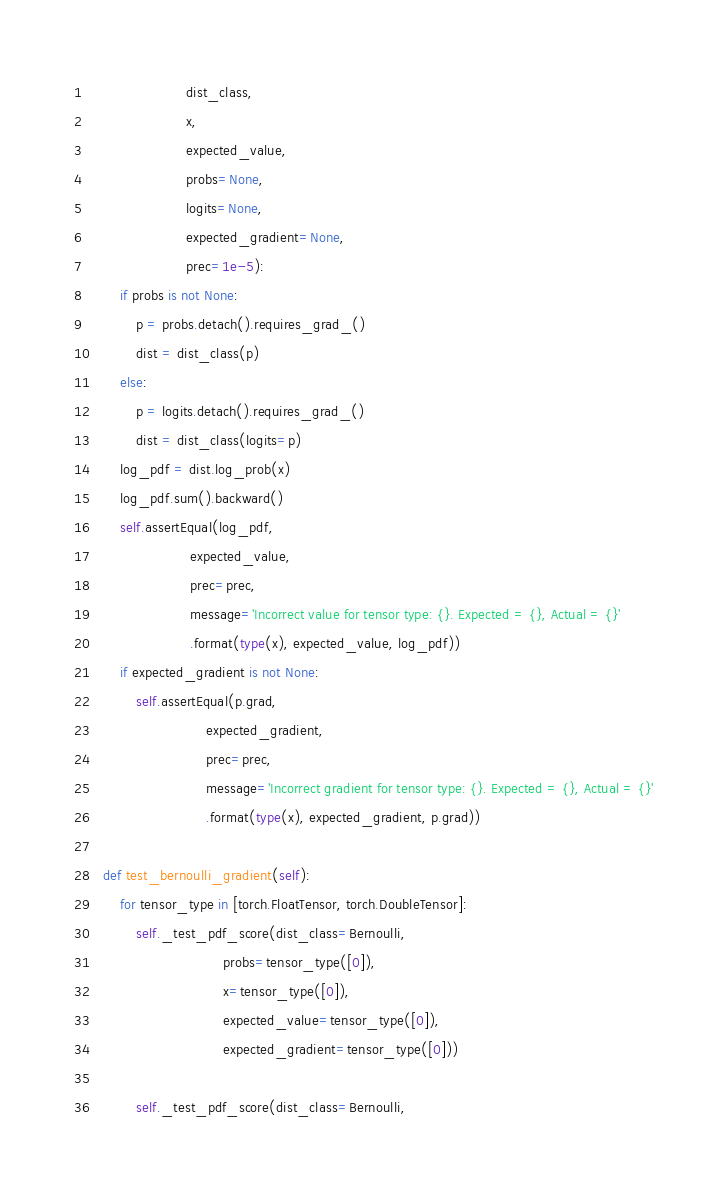Convert code to text. <code><loc_0><loc_0><loc_500><loc_500><_Python_>                        dist_class,
                        x,
                        expected_value,
                        probs=None,
                        logits=None,
                        expected_gradient=None,
                        prec=1e-5):
        if probs is not None:
            p = probs.detach().requires_grad_()
            dist = dist_class(p)
        else:
            p = logits.detach().requires_grad_()
            dist = dist_class(logits=p)
        log_pdf = dist.log_prob(x)
        log_pdf.sum().backward()
        self.assertEqual(log_pdf,
                         expected_value,
                         prec=prec,
                         message='Incorrect value for tensor type: {}. Expected = {}, Actual = {}'
                         .format(type(x), expected_value, log_pdf))
        if expected_gradient is not None:
            self.assertEqual(p.grad,
                             expected_gradient,
                             prec=prec,
                             message='Incorrect gradient for tensor type: {}. Expected = {}, Actual = {}'
                             .format(type(x), expected_gradient, p.grad))

    def test_bernoulli_gradient(self):
        for tensor_type in [torch.FloatTensor, torch.DoubleTensor]:
            self._test_pdf_score(dist_class=Bernoulli,
                                 probs=tensor_type([0]),
                                 x=tensor_type([0]),
                                 expected_value=tensor_type([0]),
                                 expected_gradient=tensor_type([0]))

            self._test_pdf_score(dist_class=Bernoulli,</code> 